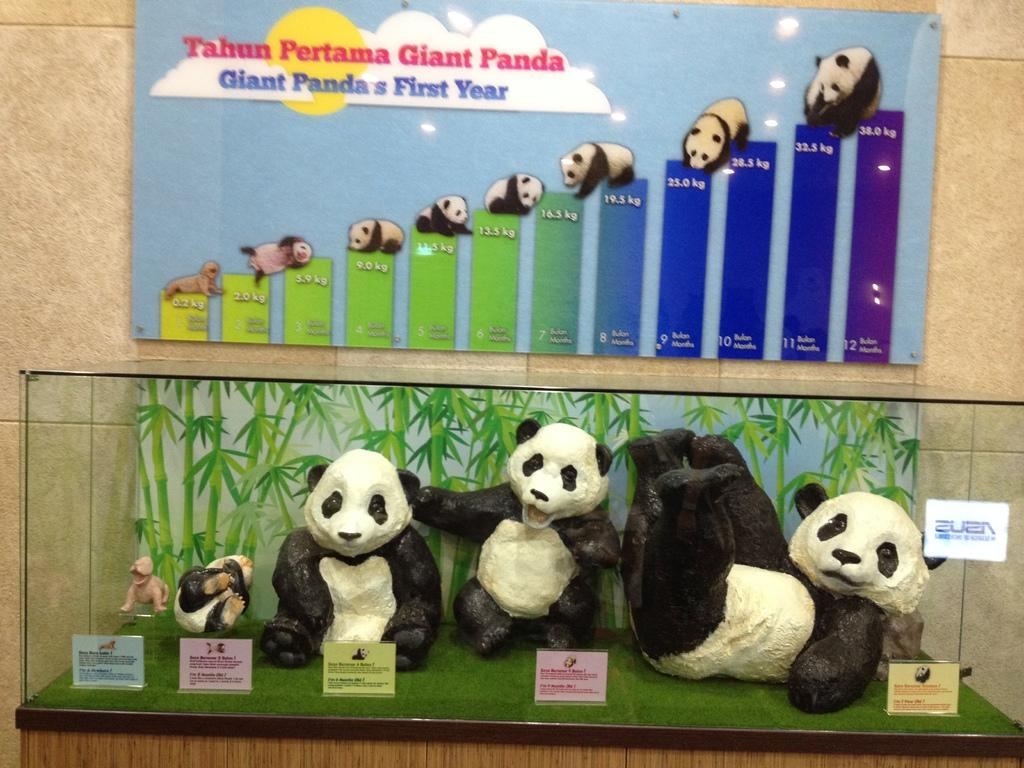What type of animals are depicted in the statues in the image? There are statues of pandas in the image. Where are the statues located? The statues are inside a mirror box. What can be seen in the background of the image? There is a wall in the background of the image. What is attached to the wall? A board is attached to the wall. Can you tell me how many pandas are swimming in the image? There are no pandas swimming in the image; the statues are inside a mirror box. What type of lamp is present in the image? There is no lamp present in the image. 